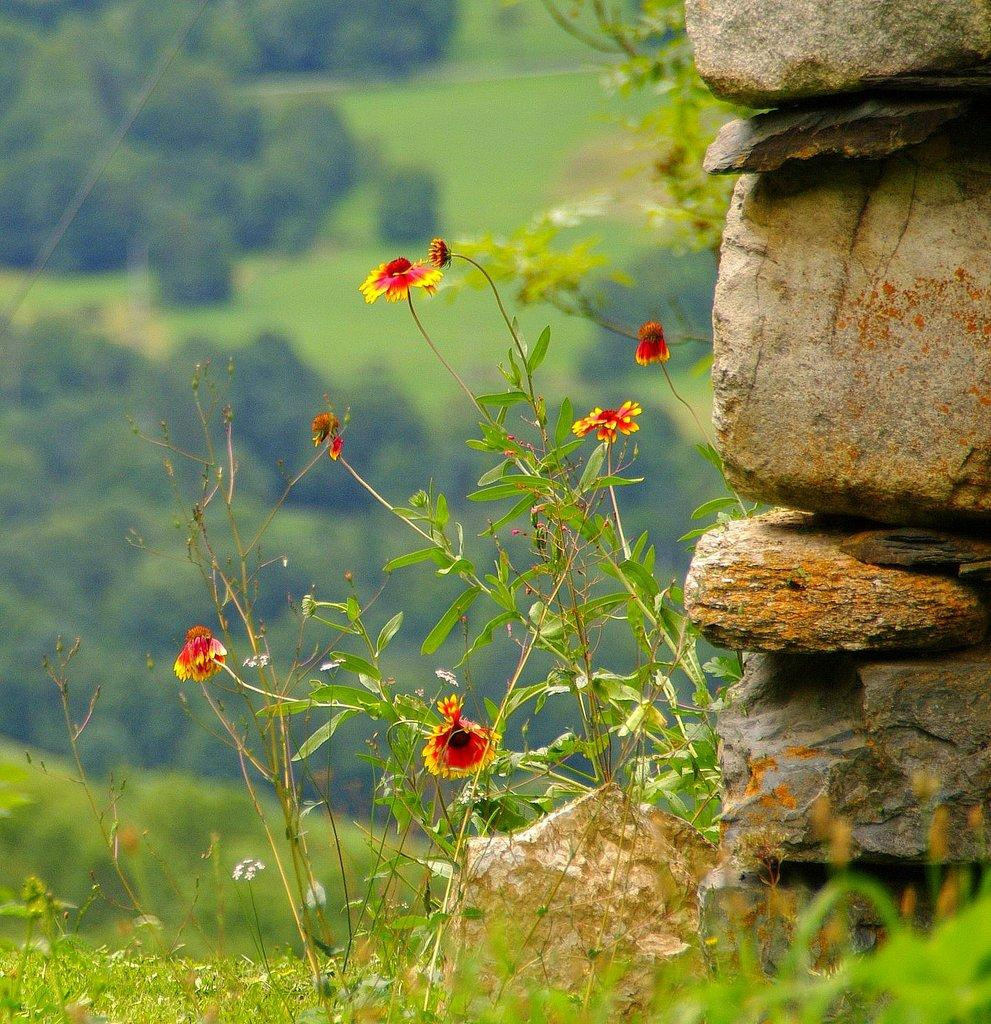What type of natural elements can be seen on the right side of the image? There are stones on the right side of the image. What is located in the foreground of the image? There are flowers on a plant in the foreground. What type of vegetation can be seen at the back of the image? There are trees visible at the back of the image. What type of ground cover is present at the bottom of the image? There is grass at the bottom of the image. Can you see the moon in the image? No, the moon is not present in the image. Is there a giraffe in the image? No, there is no giraffe in the image. 